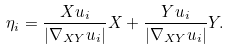Convert formula to latex. <formula><loc_0><loc_0><loc_500><loc_500>\eta _ { i } = \frac { X u _ { i } } { | \nabla _ { X Y } u _ { i } | } X + \frac { Y u _ { i } } { | \nabla _ { X Y } u _ { i } | } Y .</formula> 